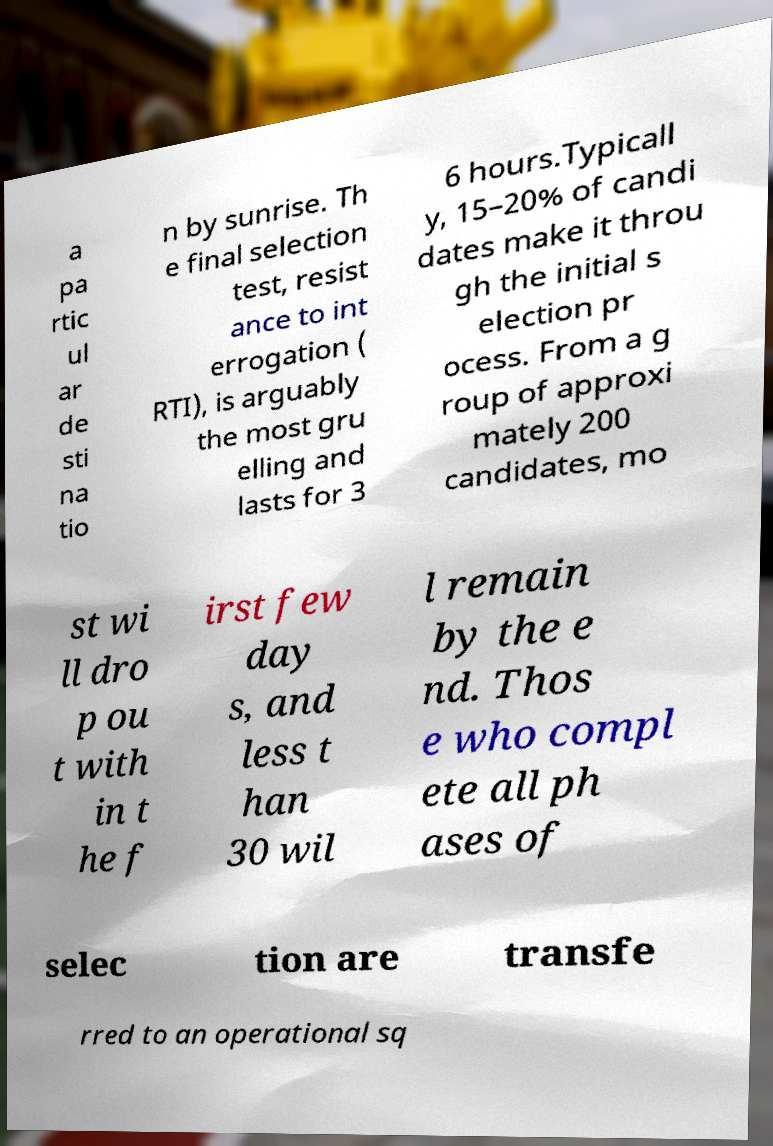Can you accurately transcribe the text from the provided image for me? a pa rtic ul ar de sti na tio n by sunrise. Th e final selection test, resist ance to int errogation ( RTI), is arguably the most gru elling and lasts for 3 6 hours.Typicall y, 15–20% of candi dates make it throu gh the initial s election pr ocess. From a g roup of approxi mately 200 candidates, mo st wi ll dro p ou t with in t he f irst few day s, and less t han 30 wil l remain by the e nd. Thos e who compl ete all ph ases of selec tion are transfe rred to an operational sq 